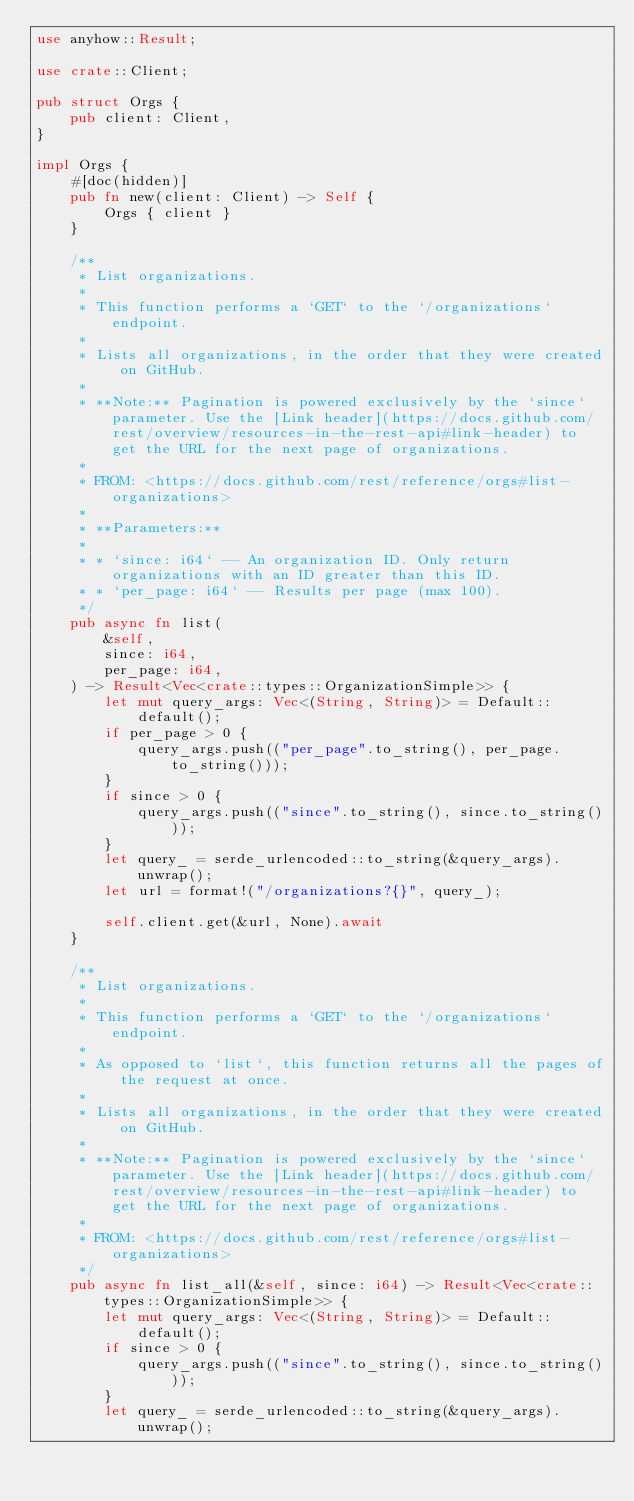<code> <loc_0><loc_0><loc_500><loc_500><_Rust_>use anyhow::Result;

use crate::Client;

pub struct Orgs {
    pub client: Client,
}

impl Orgs {
    #[doc(hidden)]
    pub fn new(client: Client) -> Self {
        Orgs { client }
    }

    /**
     * List organizations.
     *
     * This function performs a `GET` to the `/organizations` endpoint.
     *
     * Lists all organizations, in the order that they were created on GitHub.
     *
     * **Note:** Pagination is powered exclusively by the `since` parameter. Use the [Link header](https://docs.github.com/rest/overview/resources-in-the-rest-api#link-header) to get the URL for the next page of organizations.
     *
     * FROM: <https://docs.github.com/rest/reference/orgs#list-organizations>
     *
     * **Parameters:**
     *
     * * `since: i64` -- An organization ID. Only return organizations with an ID greater than this ID.
     * * `per_page: i64` -- Results per page (max 100).
     */
    pub async fn list(
        &self,
        since: i64,
        per_page: i64,
    ) -> Result<Vec<crate::types::OrganizationSimple>> {
        let mut query_args: Vec<(String, String)> = Default::default();
        if per_page > 0 {
            query_args.push(("per_page".to_string(), per_page.to_string()));
        }
        if since > 0 {
            query_args.push(("since".to_string(), since.to_string()));
        }
        let query_ = serde_urlencoded::to_string(&query_args).unwrap();
        let url = format!("/organizations?{}", query_);

        self.client.get(&url, None).await
    }

    /**
     * List organizations.
     *
     * This function performs a `GET` to the `/organizations` endpoint.
     *
     * As opposed to `list`, this function returns all the pages of the request at once.
     *
     * Lists all organizations, in the order that they were created on GitHub.
     *
     * **Note:** Pagination is powered exclusively by the `since` parameter. Use the [Link header](https://docs.github.com/rest/overview/resources-in-the-rest-api#link-header) to get the URL for the next page of organizations.
     *
     * FROM: <https://docs.github.com/rest/reference/orgs#list-organizations>
     */
    pub async fn list_all(&self, since: i64) -> Result<Vec<crate::types::OrganizationSimple>> {
        let mut query_args: Vec<(String, String)> = Default::default();
        if since > 0 {
            query_args.push(("since".to_string(), since.to_string()));
        }
        let query_ = serde_urlencoded::to_string(&query_args).unwrap();</code> 